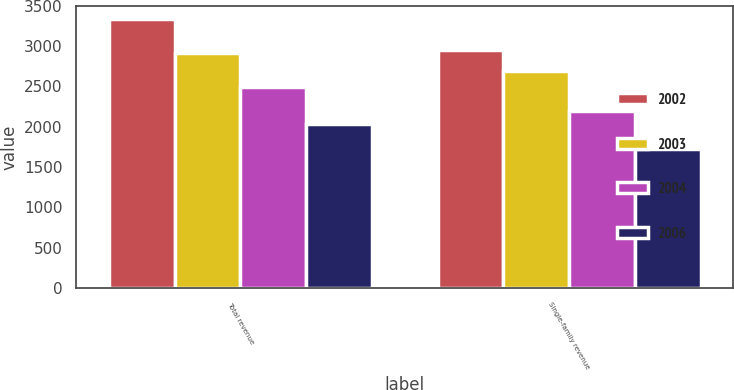Convert chart to OTSL. <chart><loc_0><loc_0><loc_500><loc_500><stacked_bar_chart><ecel><fcel>Total revenue<fcel>Single-family revenue<nl><fcel>2002<fcel>3335<fcel>2951<nl><fcel>2003<fcel>2915<fcel>2686<nl><fcel>2004<fcel>2495<fcel>2193<nl><fcel>2006<fcel>2029<fcel>1730<nl></chart> 